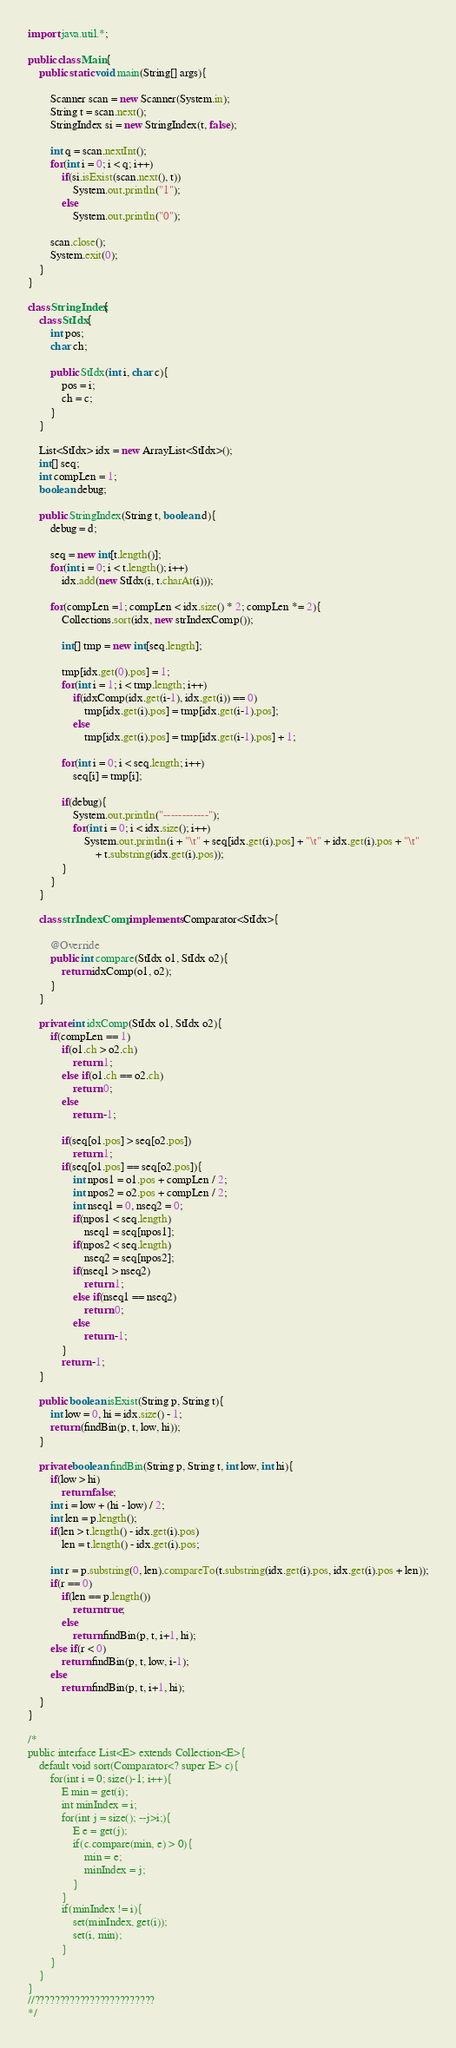<code> <loc_0><loc_0><loc_500><loc_500><_Java_>
import java.util.*;

public class Main{
	public static void main(String[] args){

		Scanner scan = new Scanner(System.in);
		String t = scan.next();
		StringIndex si = new StringIndex(t, false);

		int q = scan.nextInt();
		for(int i = 0; i < q; i++)
			if(si.isExist(scan.next(), t))
				System.out.println("1");
			else
				System.out.println("0");

		scan.close();
		System.exit(0);
	}
}

class StringIndex{
	class StIdx{
		int pos;
		char ch;

		public StIdx(int i, char c){
			pos = i;
			ch = c;
		}
	}

	List<StIdx> idx = new ArrayList<StIdx>();
	int[] seq;
	int compLen = 1;
	boolean debug;

	public StringIndex(String t, boolean d){
		debug = d;

		seq = new int[t.length()];
		for(int i = 0; i < t.length(); i++)
			idx.add(new StIdx(i, t.charAt(i)));

		for(compLen =1; compLen < idx.size() * 2; compLen *= 2){
			Collections.sort(idx, new strIndexComp());

			int[] tmp = new int[seq.length];

			tmp[idx.get(0).pos] = 1;
			for(int i = 1; i < tmp.length; i++)
				if(idxComp(idx.get(i-1), idx.get(i)) == 0)
					tmp[idx.get(i).pos] = tmp[idx.get(i-1).pos];
				else
					tmp[idx.get(i).pos] = tmp[idx.get(i-1).pos] + 1;

			for(int i = 0; i < seq.length; i++)
				seq[i] = tmp[i];

			if(debug){
				System.out.println("------------");
				for(int i = 0; i < idx.size(); i++)
					System.out.println(i + "\t" + seq[idx.get(i).pos] + "\t" + idx.get(i).pos + "\t"
						+ t.substring(idx.get(i).pos));
			}
		}
	}

	class strIndexComp implements Comparator<StIdx>{

		@Override
		public int compare(StIdx o1, StIdx o2){
			return idxComp(o1, o2);
		}
	}

	private int idxComp(StIdx o1, StIdx o2){
		if(compLen == 1)
			if(o1.ch > o2.ch)
				return 1;
			else if(o1.ch == o2.ch)
				return 0;
			else
				return -1;

			if(seq[o1.pos] > seq[o2.pos])
				return 1;
			if(seq[o1.pos] == seq[o2.pos]){
				int npos1 = o1.pos + compLen / 2;
				int npos2 = o2.pos + compLen / 2;
				int nseq1 = 0, nseq2 = 0;
				if(npos1 < seq.length)
					nseq1 = seq[npos1];
				if(npos2 < seq.length)
					nseq2 = seq[npos2];
				if(nseq1 > nseq2)
					return 1;
				else if(nseq1 == nseq2)
					return 0;
				else
					return -1;
			}
			return -1;
	}

	public boolean isExist(String p, String t){
		int low = 0, hi = idx.size() - 1;
		return (findBin(p, t, low, hi));
	}

	private boolean findBin(String p, String t, int low, int hi){
		if(low > hi)
			return false;
		int i = low + (hi - low) / 2;
		int len = p.length();
		if(len > t.length() - idx.get(i).pos)
			len = t.length() - idx.get(i).pos;

		int r = p.substring(0, len).compareTo(t.substring(idx.get(i).pos, idx.get(i).pos + len));
		if(r == 0)
			if(len == p.length())
				return true;
			else
				return findBin(p, t, i+1, hi);
		else if(r < 0)
			return findBin(p, t, low, i-1);
		else
			return findBin(p, t, i+1, hi);
	}
}

/*
public interface List<E> extends Collection<E>{
	default void sort(Comparator<? super E> c){
		for(int i = 0; size()-1; i++){
			E min = get(i);
			int minIndex = i;
			for(int j = size(); --j>i;){
				E e = get(j);
				if(c.compare(min, e) > 0){
					min = e;
					minIndex = j;
				}
			}
			if(minIndex != i){
				set(minIndex, get(i));
				set(i, min);
			}
		}
	}
}
//????????????????????????
*/</code> 